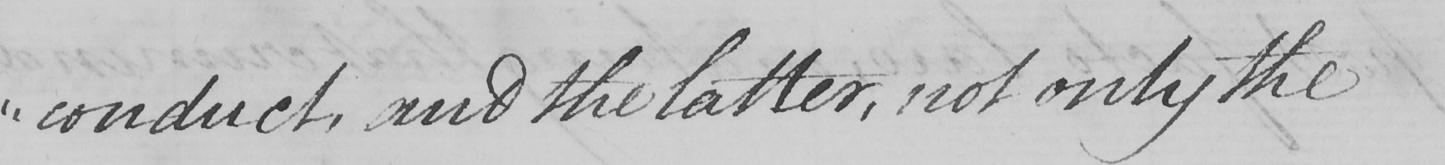Can you tell me what this handwritten text says? " conduct , and the latter , not only the 